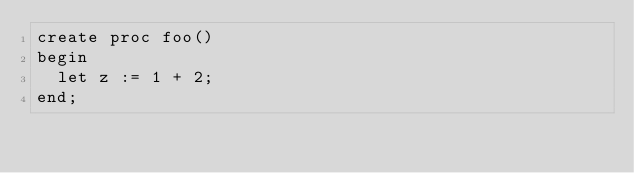Convert code to text. <code><loc_0><loc_0><loc_500><loc_500><_SQL_>create proc foo()
begin
  let z := 1 + 2;
end;
</code> 